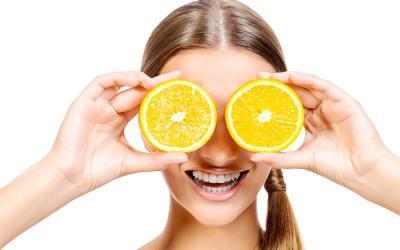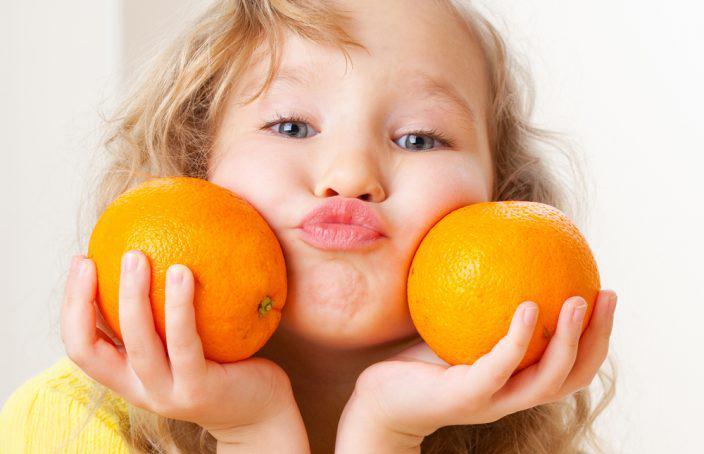The first image is the image on the left, the second image is the image on the right. Analyze the images presented: Is the assertion "One person is holding an orange slice over at least one of their eyes." valid? Answer yes or no. Yes. The first image is the image on the left, the second image is the image on the right. Examine the images to the left and right. Is the description "In one image, a woman is holding one or more slices of orange to her face, while a child in a second image is holding up an orange or part of one in each hand." accurate? Answer yes or no. Yes. 